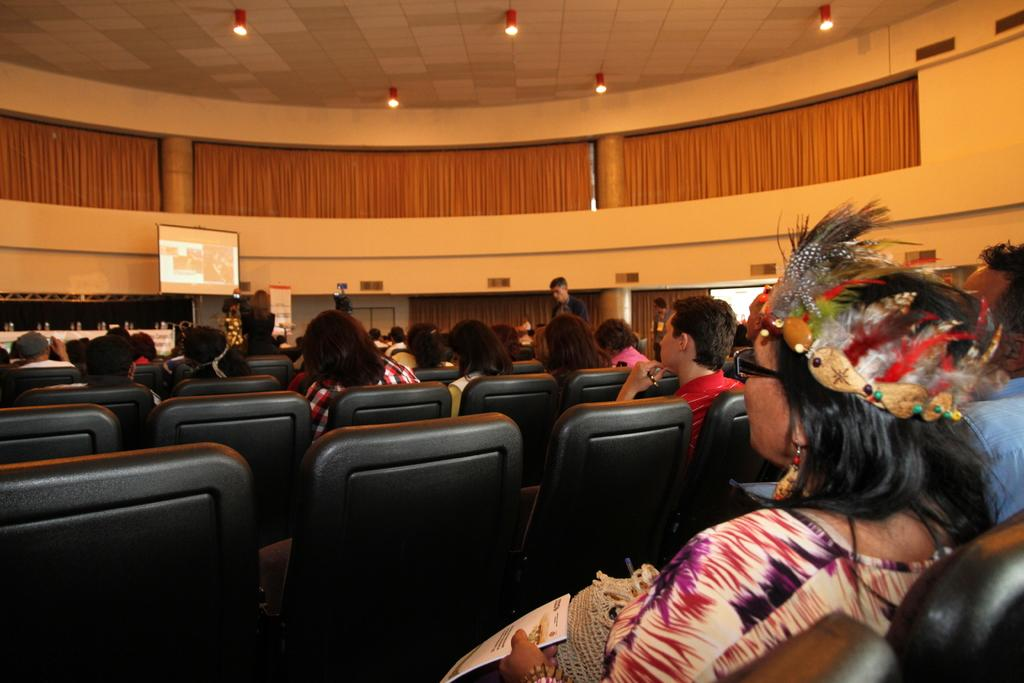What are the people in the image doing? The people in the image are sitting on chairs. What can be seen in the background of the image? There is a projector screen and curtains in the background of the image. What type of lighting is present in the image? There are lights on the ceiling in the image. What type of map or territory is depicted on the projector screen? There is no map or territory visible on the projector screen in the image. What songs are being played in the background of the image? There is no information about any songs being played in the image. 